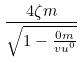Convert formula to latex. <formula><loc_0><loc_0><loc_500><loc_500>\frac { 4 \zeta m } { \sqrt { 1 - \frac { 0 m } { v u ^ { 0 } } } }</formula> 